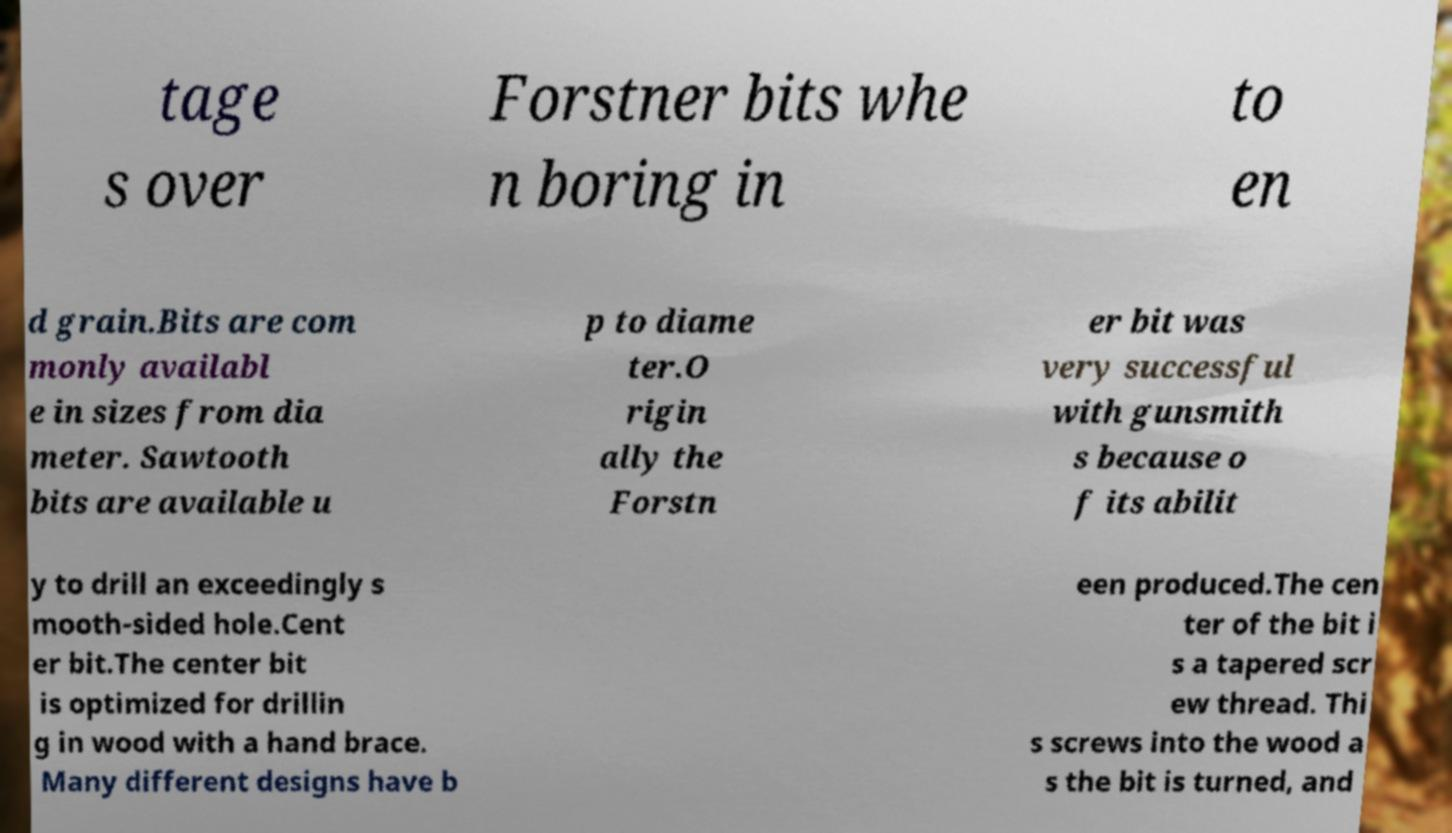For documentation purposes, I need the text within this image transcribed. Could you provide that? tage s over Forstner bits whe n boring in to en d grain.Bits are com monly availabl e in sizes from dia meter. Sawtooth bits are available u p to diame ter.O rigin ally the Forstn er bit was very successful with gunsmith s because o f its abilit y to drill an exceedingly s mooth-sided hole.Cent er bit.The center bit is optimized for drillin g in wood with a hand brace. Many different designs have b een produced.The cen ter of the bit i s a tapered scr ew thread. Thi s screws into the wood a s the bit is turned, and 